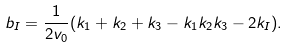Convert formula to latex. <formula><loc_0><loc_0><loc_500><loc_500>b _ { I } = \frac { 1 } { 2 v _ { 0 } } ( k _ { 1 } + k _ { 2 } + k _ { 3 } - k _ { 1 } k _ { 2 } k _ { 3 } - 2 k _ { I } ) .</formula> 